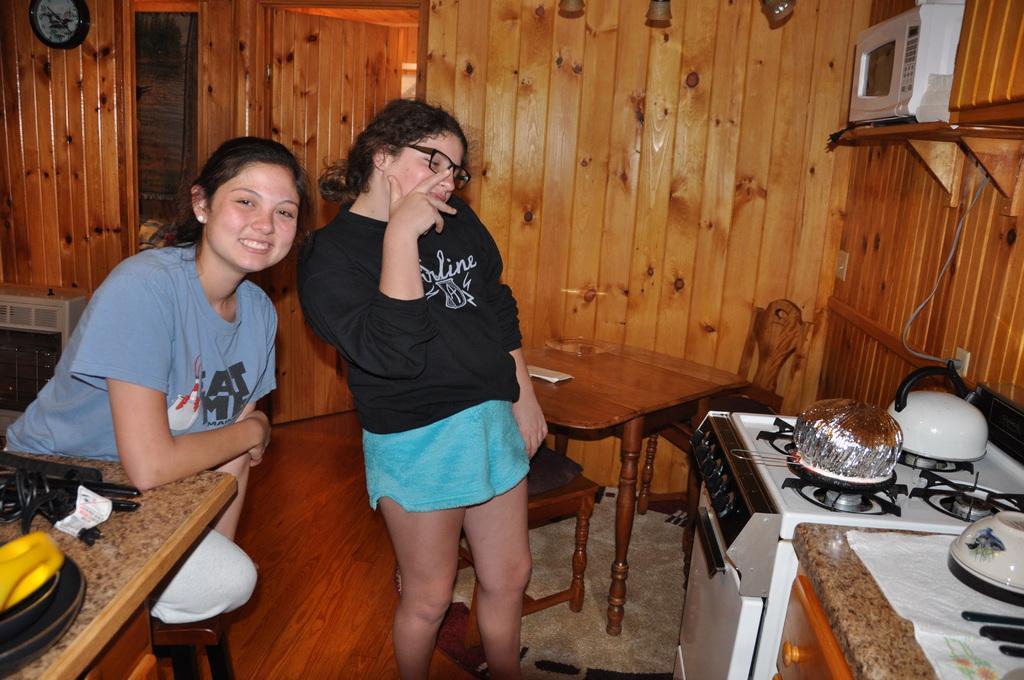Describe this image in one or two sentences. In this picture there are two ladies. To the left side there is a lady with blue t-shirt is sitting on the table. And she is smiling. Beside her there is another lady with black t-shirt is standing. She is wearing spectacles. And to the left bottom corner there is a table with two objects on it. And to the right bottom there is a stove and table. On the table there are bowls and knife. And on the stove there are two bowls. Into the right top there is a door. 